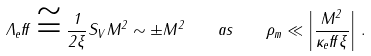<formula> <loc_0><loc_0><loc_500><loc_500>\Lambda _ { e } f f \cong \frac { 1 } { 2 \xi } S _ { V } M ^ { 2 } \sim \pm M ^ { 2 } \quad a s \quad \rho _ { m } \ll \left | \frac { M ^ { 2 } } { \kappa _ { e } f f \xi } \right | \, .</formula> 